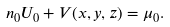<formula> <loc_0><loc_0><loc_500><loc_500>n _ { 0 } U _ { 0 } + V ( x , y , z ) = \mu _ { 0 } .</formula> 